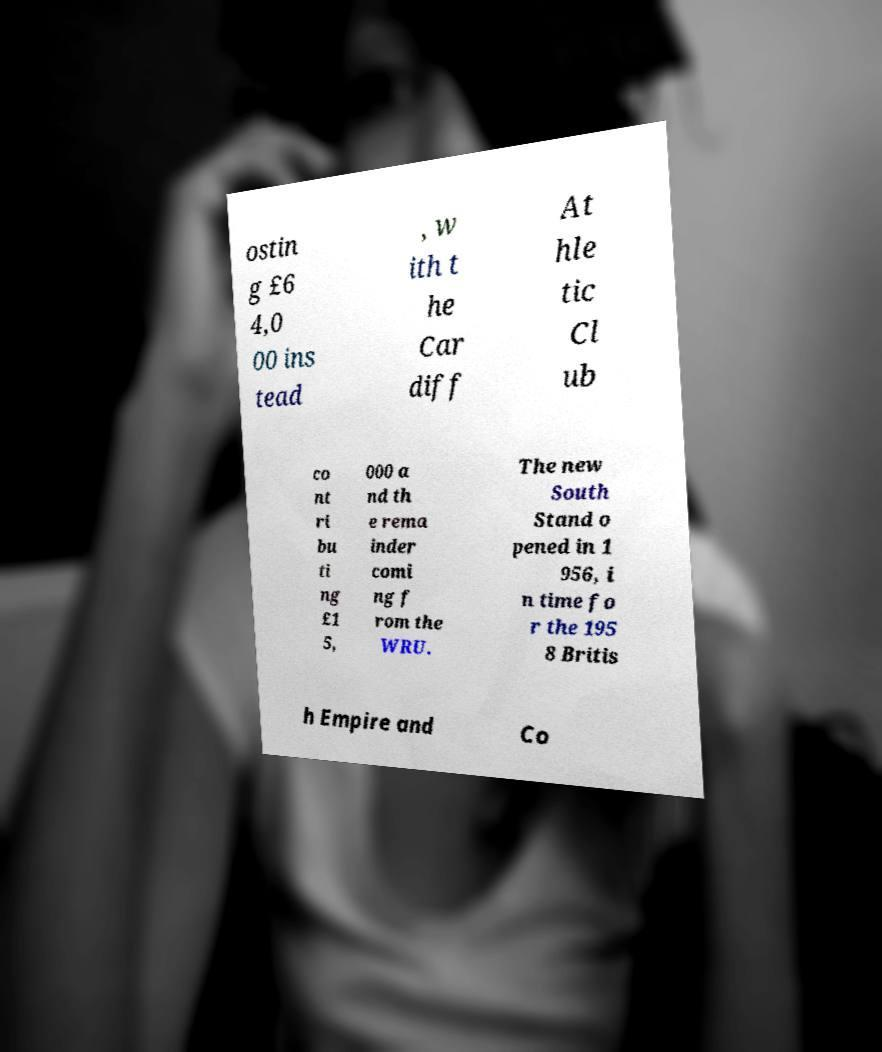For documentation purposes, I need the text within this image transcribed. Could you provide that? ostin g £6 4,0 00 ins tead , w ith t he Car diff At hle tic Cl ub co nt ri bu ti ng £1 5, 000 a nd th e rema inder comi ng f rom the WRU. The new South Stand o pened in 1 956, i n time fo r the 195 8 Britis h Empire and Co 